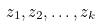Convert formula to latex. <formula><loc_0><loc_0><loc_500><loc_500>z _ { 1 } , z _ { 2 } , \dots , z _ { k }</formula> 